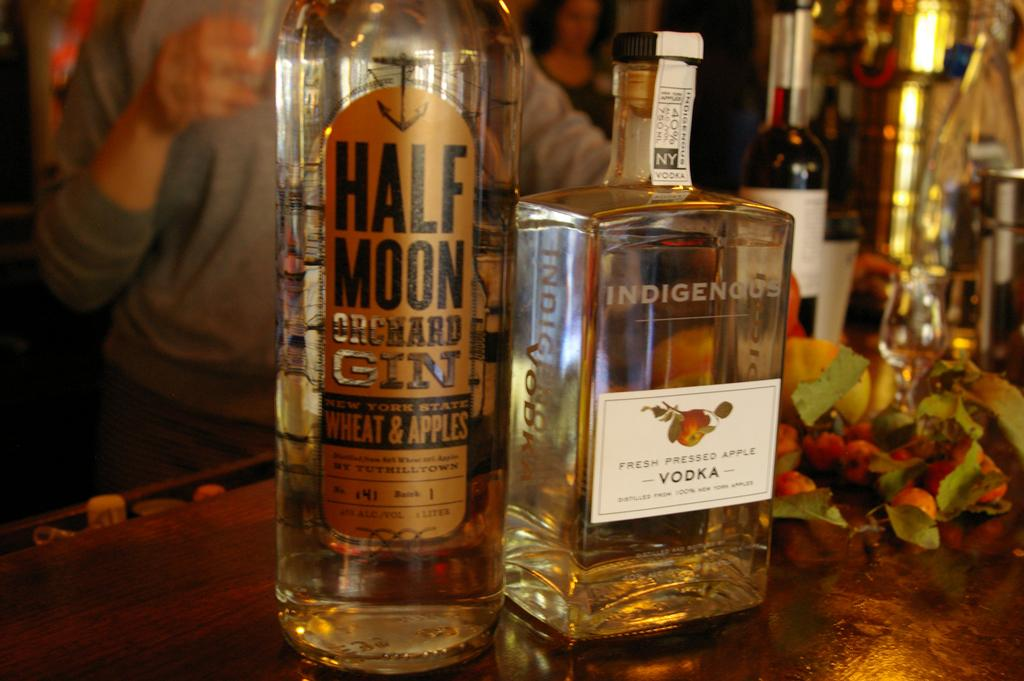<image>
Write a terse but informative summary of the picture. a bottle of vodka and a bottle of gin sitting next to each other on a table. 